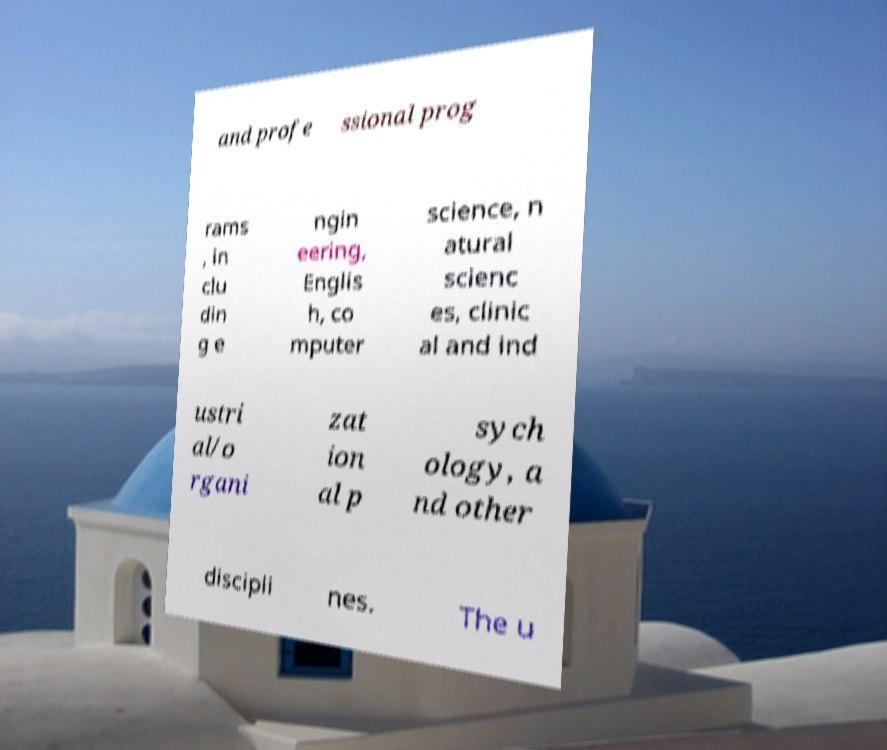Could you extract and type out the text from this image? and profe ssional prog rams , in clu din g e ngin eering, Englis h, co mputer science, n atural scienc es, clinic al and ind ustri al/o rgani zat ion al p sych ology, a nd other discipli nes. The u 